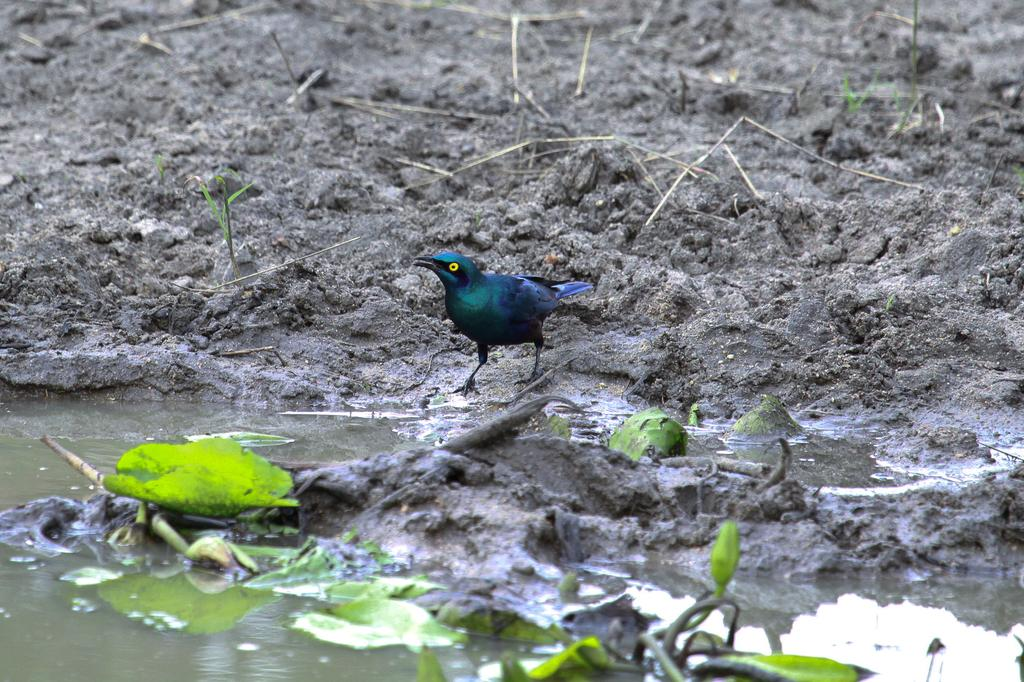What is depicted on the mud in the image? There is a bird represented on the mud in the image. What can be seen in the background of the image? There is water visible in the image. What type of vegetation is present in the image? There are leaves in the image. What type of learning can be observed taking place in the hospital depicted in the image? There is no hospital depicted in the image, and no learning is taking place. 